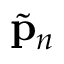Convert formula to latex. <formula><loc_0><loc_0><loc_500><loc_500>\tilde { p } _ { n }</formula> 